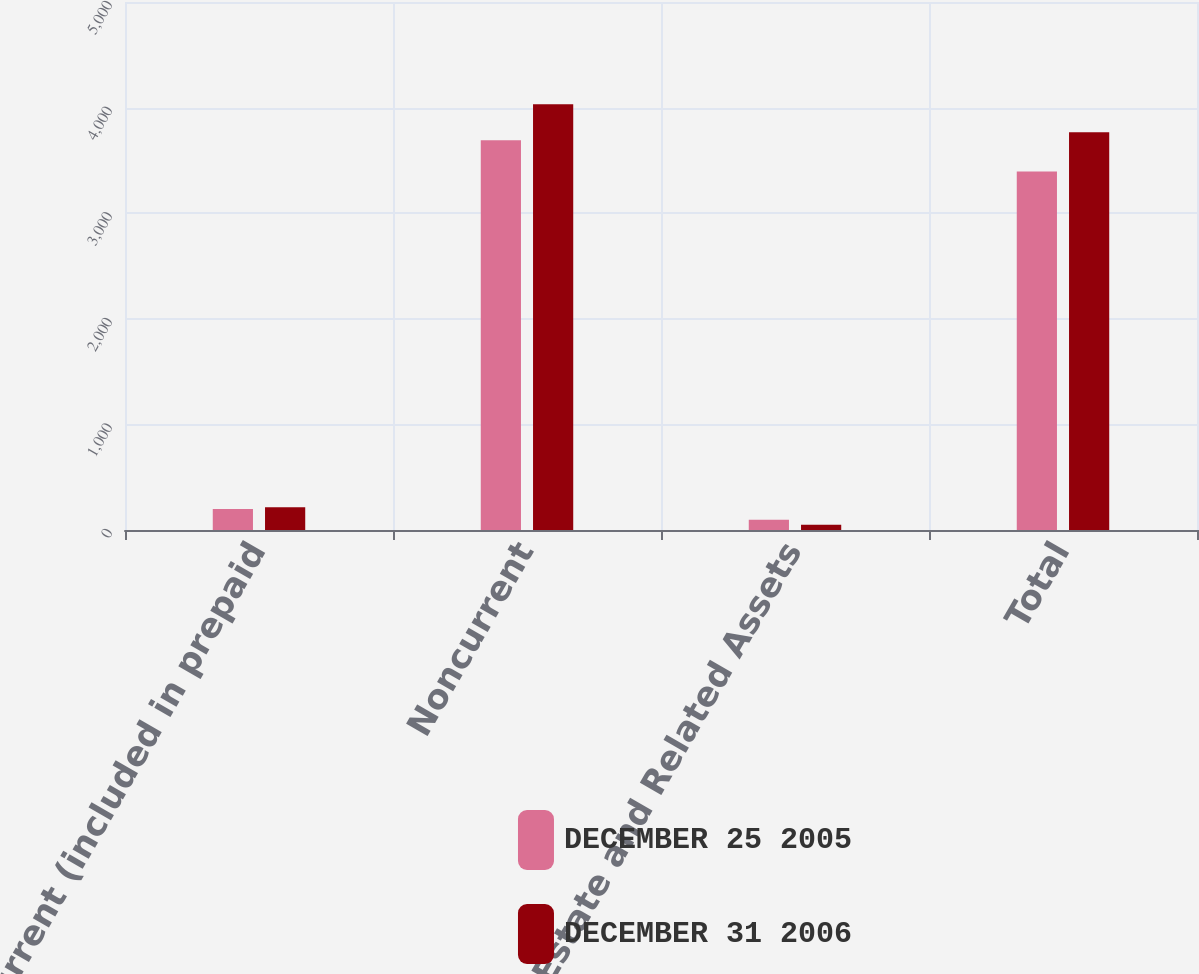<chart> <loc_0><loc_0><loc_500><loc_500><stacked_bar_chart><ecel><fcel>Current (included in prepaid<fcel>Noncurrent<fcel>Real Estate and Related Assets<fcel>Total<nl><fcel>DECEMBER 25 2005<fcel>199<fcel>3691<fcel>98<fcel>3394<nl><fcel>DECEMBER 31 2006<fcel>216<fcel>4032<fcel>50<fcel>3766<nl></chart> 